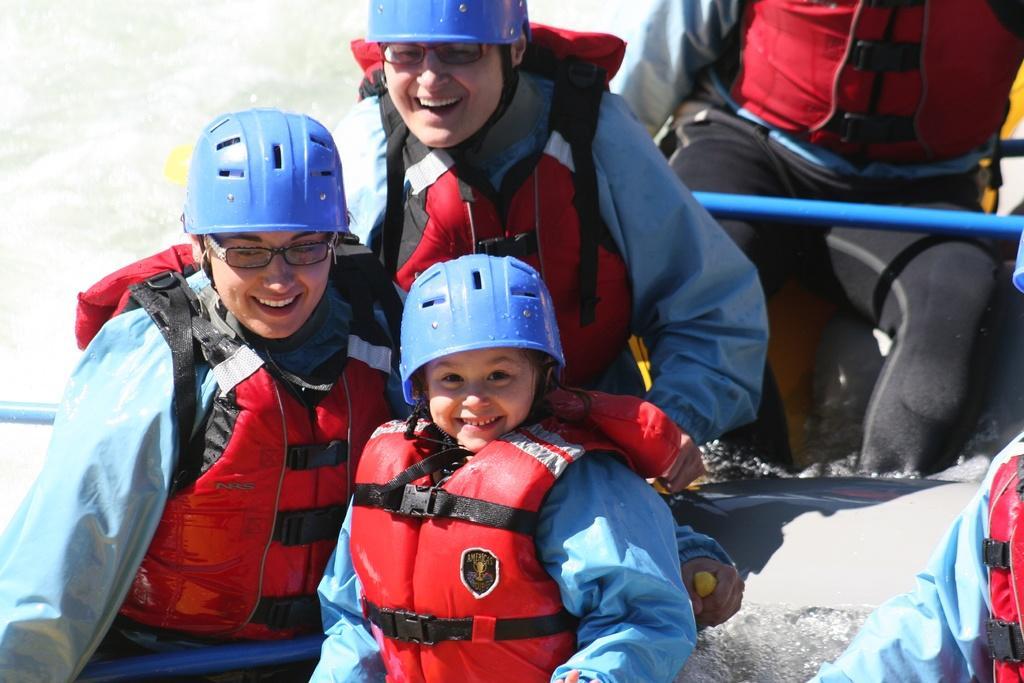Could you give a brief overview of what you see in this image? In this image, I can see few people siting on a rafting boat. These people wore life jackets and helmets. In the background, I can see water. 